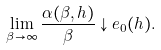Convert formula to latex. <formula><loc_0><loc_0><loc_500><loc_500>\lim _ { \beta \to \infty } \frac { \alpha ( \beta , h ) } { \beta } \downarrow e _ { 0 } ( h ) .</formula> 